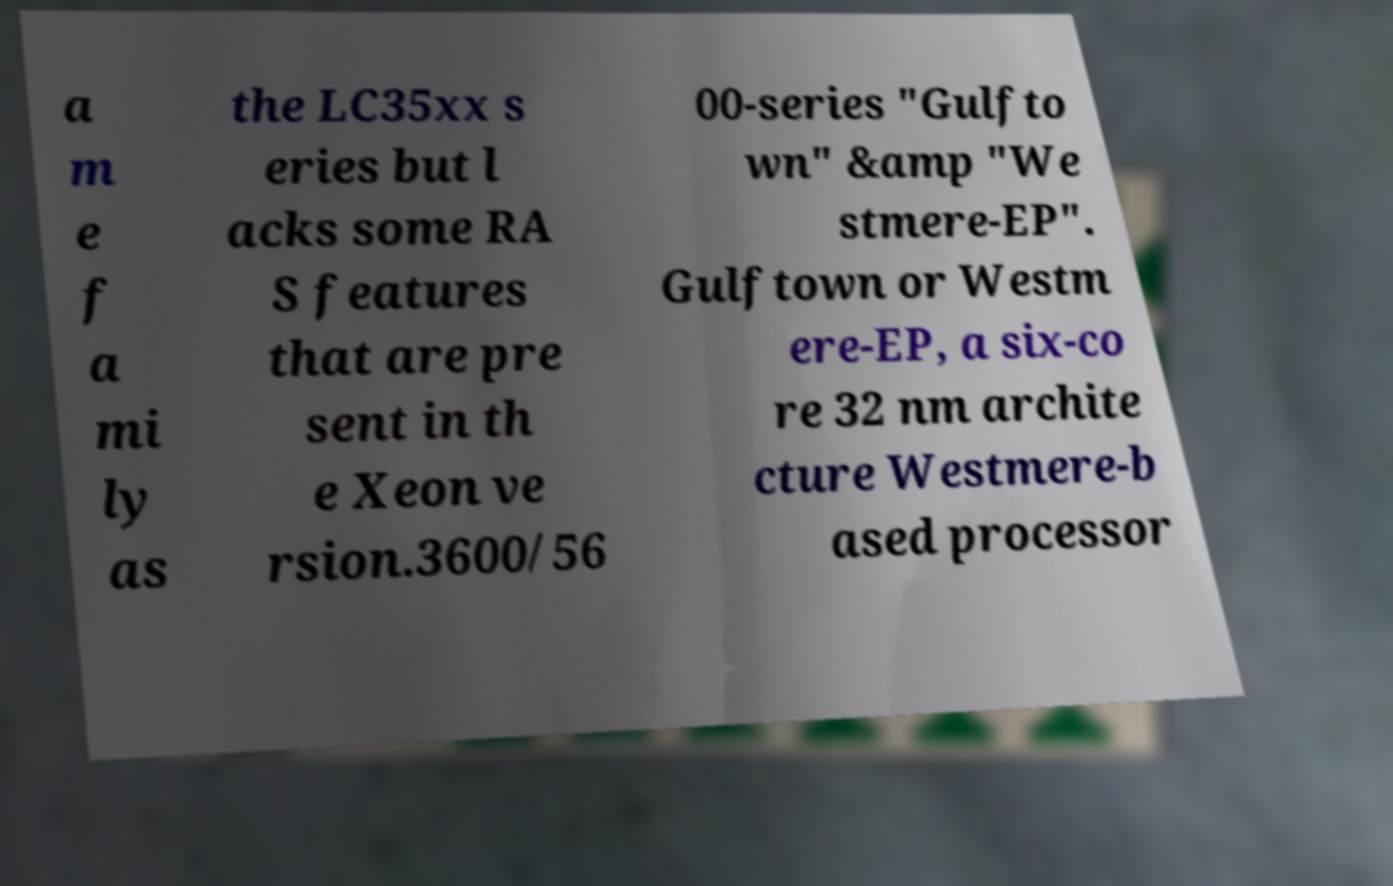I need the written content from this picture converted into text. Can you do that? a m e f a mi ly as the LC35xx s eries but l acks some RA S features that are pre sent in th e Xeon ve rsion.3600/56 00-series "Gulfto wn" &amp "We stmere-EP". Gulftown or Westm ere-EP, a six-co re 32 nm archite cture Westmere-b ased processor 